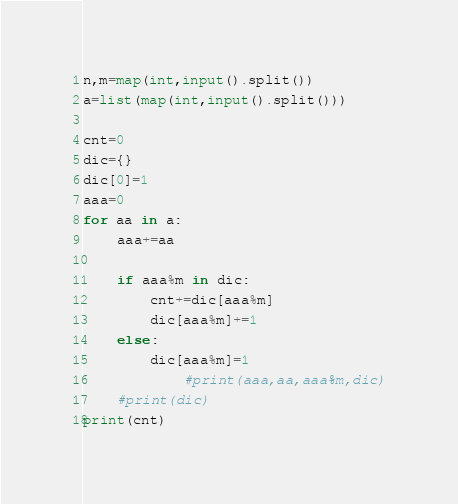<code> <loc_0><loc_0><loc_500><loc_500><_Python_>n,m=map(int,input().split())
a=list(map(int,input().split()))

cnt=0
dic={}
dic[0]=1
aaa=0
for aa in a:
    aaa+=aa

    if aaa%m in dic:
        cnt+=dic[aaa%m]
        dic[aaa%m]+=1
    else:
        dic[aaa%m]=1
            #print(aaa,aa,aaa%m,dic)
    #print(dic)
print(cnt)

</code> 